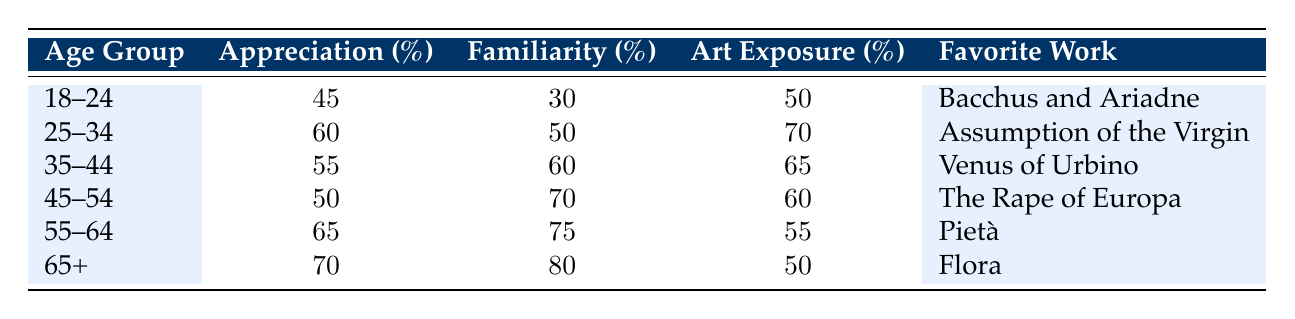What is the percentage of appreciation for the 25-34 age group? The table indicates that the 25-34 age group has a percentage appreciation listed in the second column. According to the table, this percentage is 60.
Answer: 60 Which age group has the highest familiarity with Titian? By examining the "Familiarity (%)" column, the age group with the highest value is the 65+ group, which has a familiarity percentage of 80.
Answer: 65+ What is the average exposure to art across all age groups? To find the average, sum the exposure percentages from all groups: (50 + 70 + 65 + 60 + 55 + 50) = 350. Then divide by the number of groups, which is 6: 350/6 = approximately 58.33.
Answer: 58.33 Is there an age group that has a percentage appreciation of over 65%? Looking at the "Appreciation (%)" column, the age groups 55-64 (65%) and 65+ (70%) both exceed 65%. Thus, there are age groups that fit this criterion.
Answer: Yes What is the favorite work of the 45-54 age group? The table lists "Favorite Work" under the last column. For the age group 45-54, the favorite work noted is "The Rape of Europa."
Answer: The Rape of Europa Which age group shows the largest difference in appreciation between those who are familiar with Titian and those who are not? To determine this, find the familiarity and appreciation for each age group. Calculate the difference for each group where appreciation can be compared to familiarity. The largest difference is found by examining rows: 18-24 has 45 - 30 = 15, and 25-34 has 60 - 50 = 10, 35-44 has 55 - 60 = -5, and so on. The largest difference is thus in the 18-24 age group with a difference of 15.
Answer: 18-24 How does the percentage of appreciation compare between the 55-64 and 65+ age groups? Check the "Percentage Appreciation" for both groups: the 55-64 age group's appreciation is 65%, while the 65+ age group has 70%. Comparatively, the 65+ age group has a higher appreciation percentage by 5%.
Answer: 5% more for 65+ What can be inferred about the age group's art exposure in relation to their appreciation for Titian's work? By observing the table, it appears that as age increases, both familiarity and appreciation tend to rise alongside a generally steady or decreasing level of art exposure, suggesting that higher exposure does not directly correlate with appreciation. For example, the 55-64 age group has less exposure (55%) but greater appreciation (65%) than the younger groups.
Answer: Higher age relates to higher appreciation despite varying exposure 